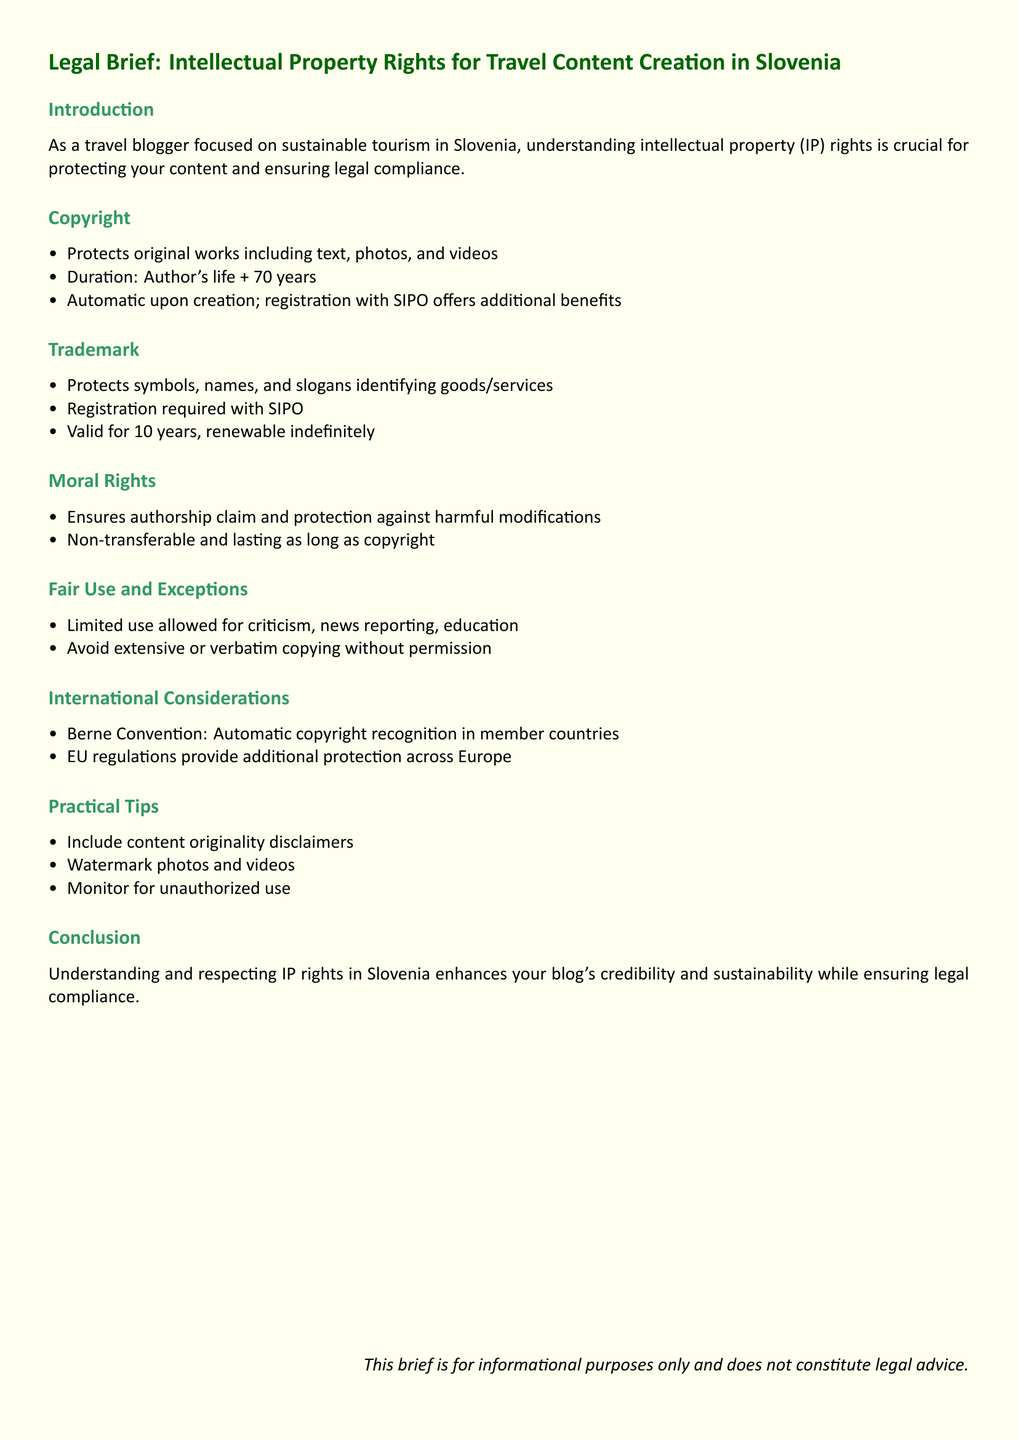What protections does Copyright provide? Copyright protects original works including text, photos, and videos.
Answer: Original works including text, photos, and videos What is the duration of Copyright in Slovenia? The duration of Copyright is the author's life plus 70 years.
Answer: Author's life + 70 years How long is a Trademark valid for in Slovenia? A Trademark is valid for 10 years, renewable indefinitely.
Answer: 10 years What is the purpose of Moral Rights? Moral Rights ensure authorship claim and protection against harmful modifications.
Answer: Authorship claim and protection against harmful modifications What is the main exception to Copyright in the document? The main exception allows limited use for criticism, news reporting, and education.
Answer: Criticism, news reporting, education What international agreement is mentioned for automatic copyright recognition? The Berne Convention is mentioned for automatic copyright recognition in member countries.
Answer: Berne Convention What does the document advise regarding content originality? The document advises to include content originality disclaimers.
Answer: Include content originality disclaimers What type of document is this? This document is a Legal Brief.
Answer: Legal Brief 